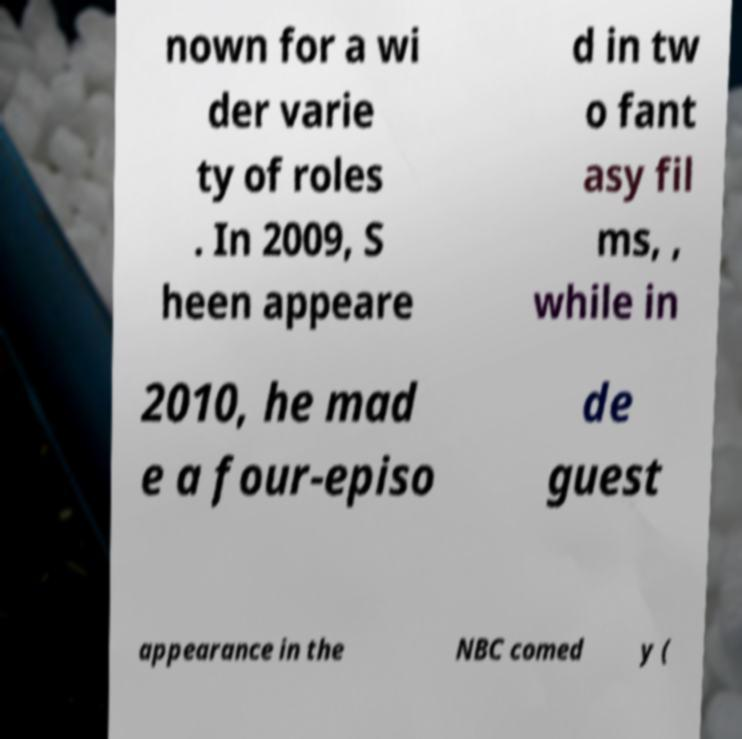There's text embedded in this image that I need extracted. Can you transcribe it verbatim? nown for a wi der varie ty of roles . In 2009, S heen appeare d in tw o fant asy fil ms, , while in 2010, he mad e a four-episo de guest appearance in the NBC comed y ( 